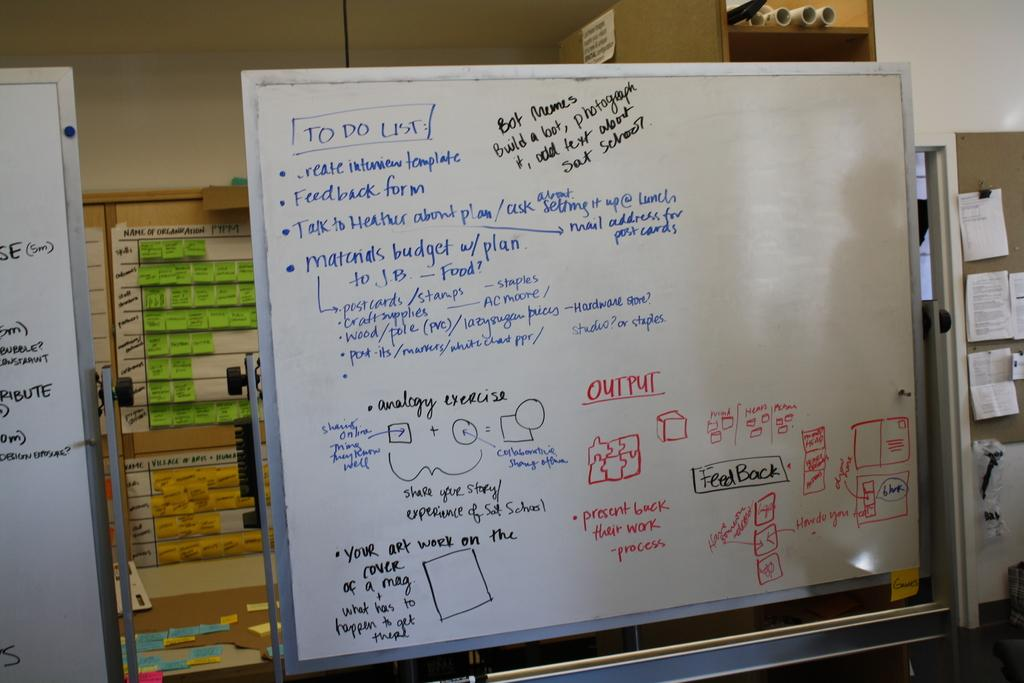<image>
Render a clear and concise summary of the photo. A to do list that includes a feedback form and talking to heather as well as output. 